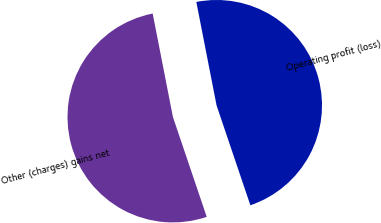Convert chart. <chart><loc_0><loc_0><loc_500><loc_500><pie_chart><fcel>Other (charges) gains net<fcel>Operating profit (loss)<nl><fcel>52.12%<fcel>47.88%<nl></chart> 